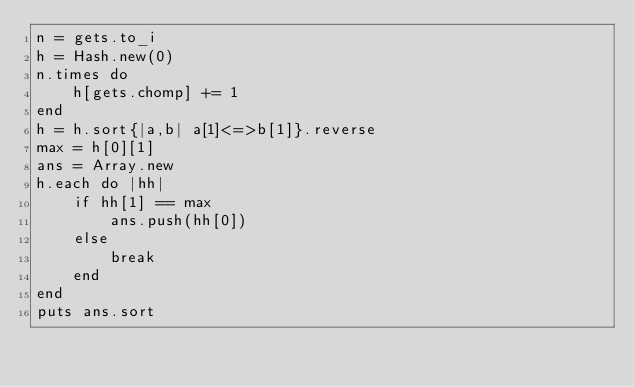<code> <loc_0><loc_0><loc_500><loc_500><_Ruby_>n = gets.to_i
h = Hash.new(0)
n.times do
    h[gets.chomp] += 1
end
h = h.sort{|a,b| a[1]<=>b[1]}.reverse
max = h[0][1]
ans = Array.new
h.each do |hh|
    if hh[1] == max
        ans.push(hh[0])
    else
        break
    end
end
puts ans.sort</code> 